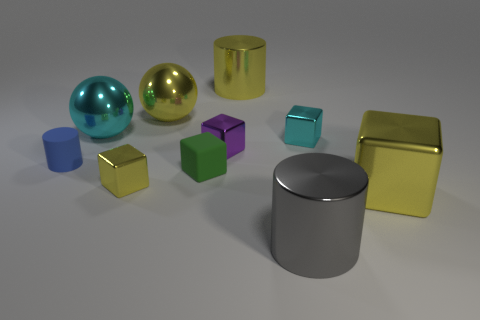Can you tell me which objects seem to be of similar size? The blue and green cubes appear to be of similar size, both larger than the tiny golden cube but smaller than the other objects depicted. 